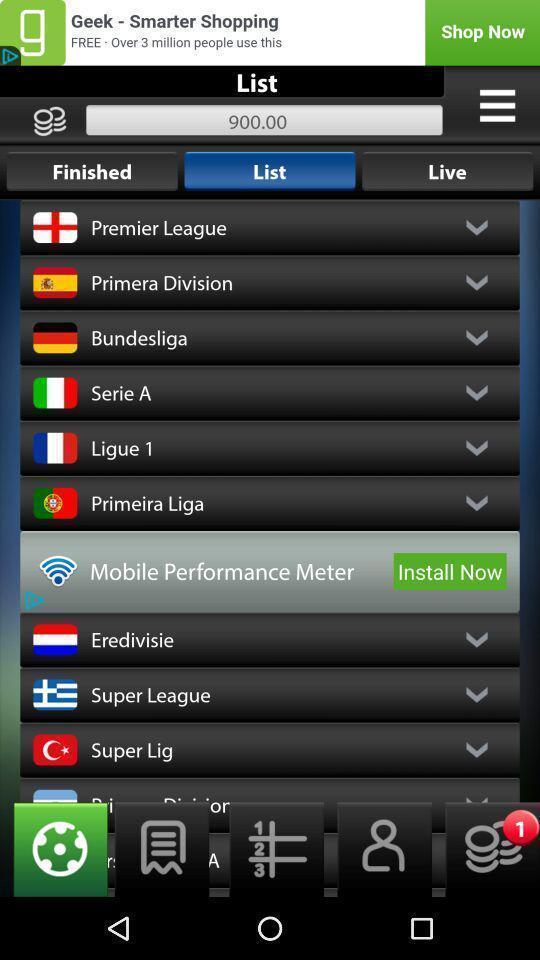Explain the elements present in this screenshot. Screen displaying the list of teams. 